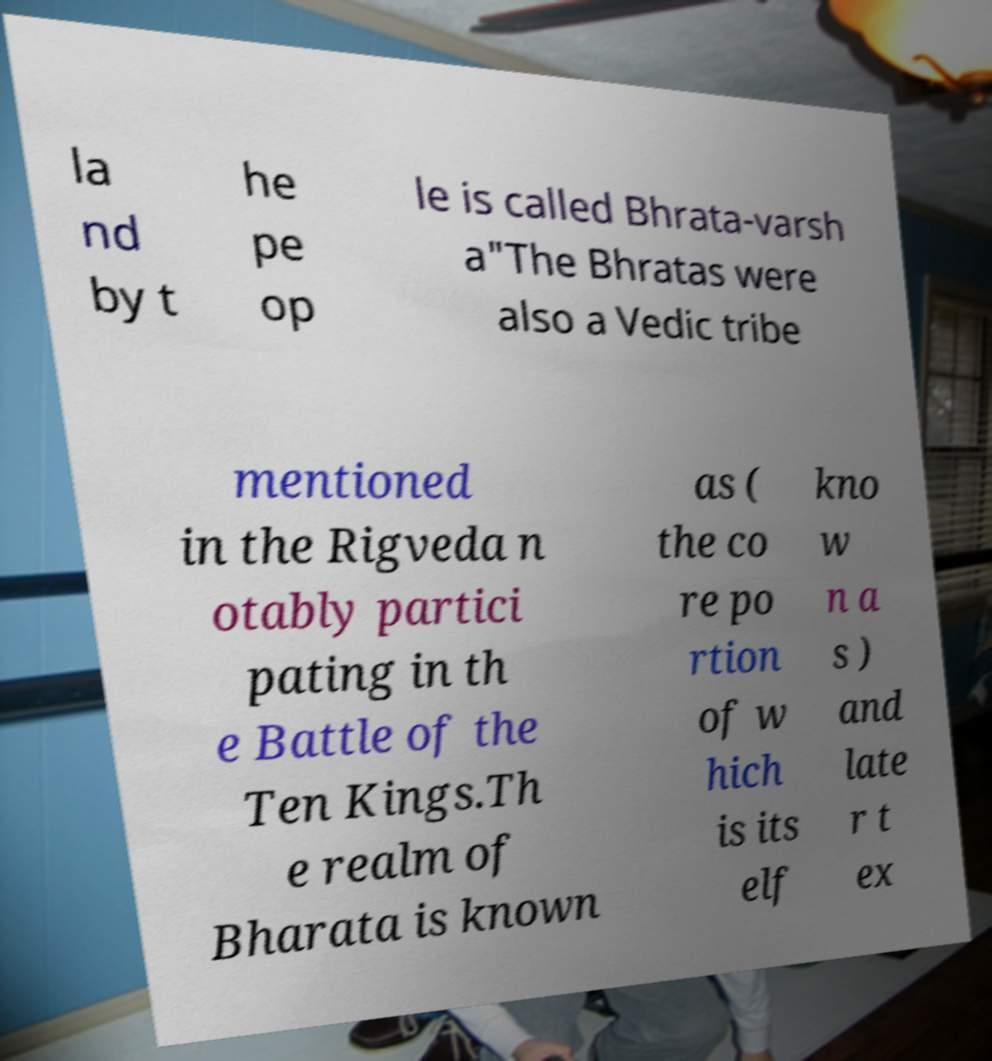I need the written content from this picture converted into text. Can you do that? la nd by t he pe op le is called Bhrata-varsh a"The Bhratas were also a Vedic tribe mentioned in the Rigveda n otably partici pating in th e Battle of the Ten Kings.Th e realm of Bharata is known as ( the co re po rtion of w hich is its elf kno w n a s ) and late r t ex 